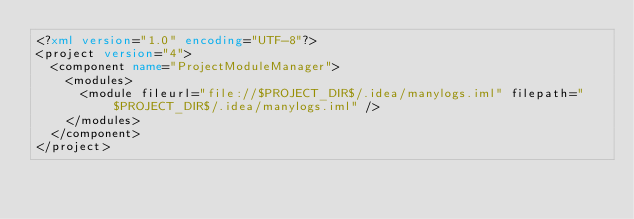Convert code to text. <code><loc_0><loc_0><loc_500><loc_500><_XML_><?xml version="1.0" encoding="UTF-8"?>
<project version="4">
  <component name="ProjectModuleManager">
    <modules>
      <module fileurl="file://$PROJECT_DIR$/.idea/manylogs.iml" filepath="$PROJECT_DIR$/.idea/manylogs.iml" />
    </modules>
  </component>
</project></code> 